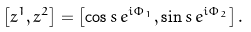Convert formula to latex. <formula><loc_0><loc_0><loc_500><loc_500>\left [ z ^ { 1 } , z ^ { 2 } \right ] = \left [ \cos s \, e ^ { i \Phi _ { 1 } } , \sin s \, e ^ { i \Phi _ { 2 } } \right ] .</formula> 